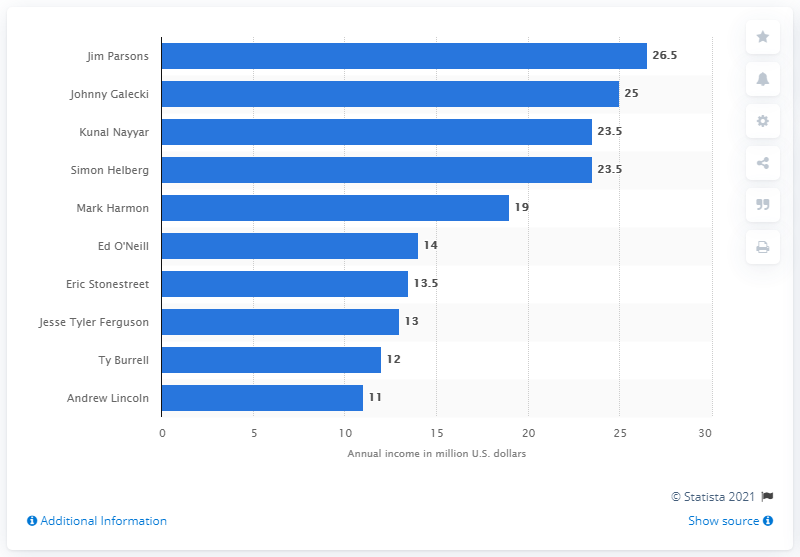Indicate a few pertinent items in this graphic. The highest paid actor of the season is Jim Parsons. 